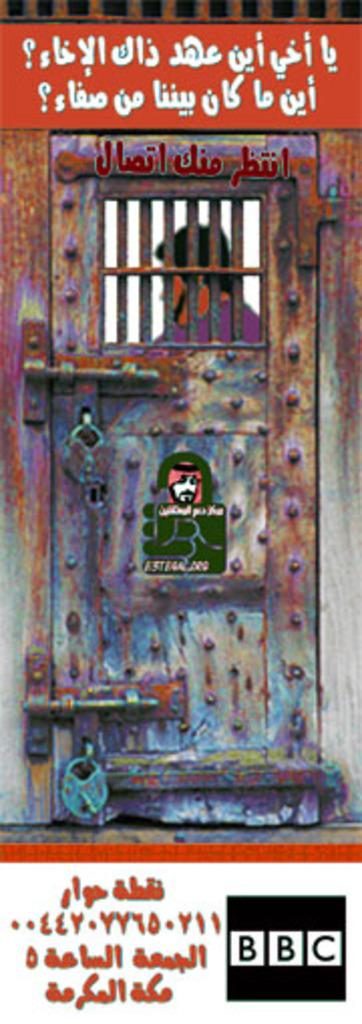<image>
Provide a brief description of the given image. A BBC poster shows a man locked inside of a jail cell 